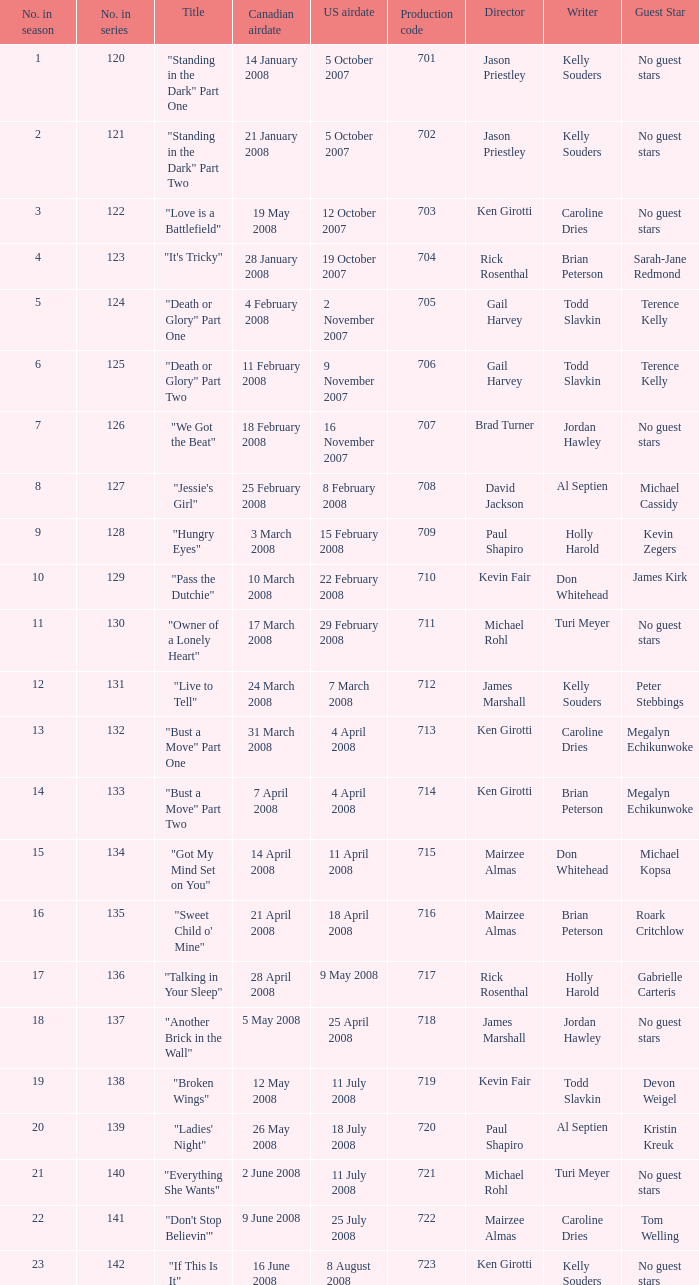The canadian airdate of 11 february 2008 applied to what series number? 1.0. 